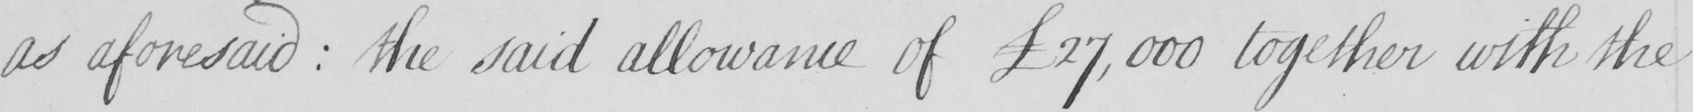Please transcribe the handwritten text in this image. as aforesaid  :  the said allowance of £27,000 together with the 